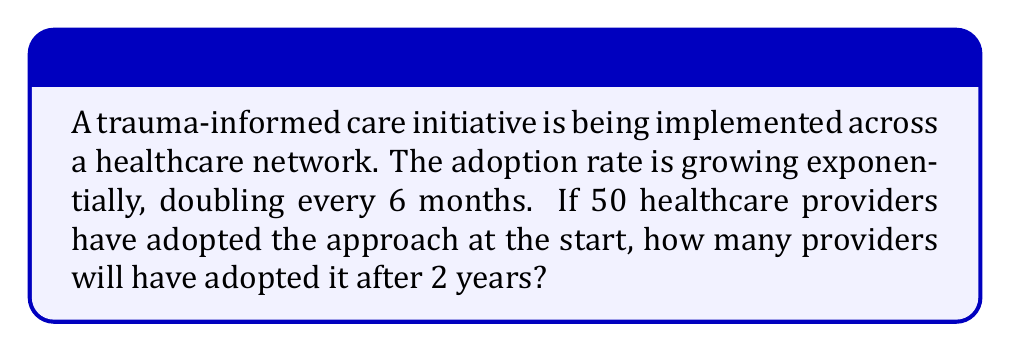Can you solve this math problem? Let's approach this step-by-step:

1) First, we need to identify our initial value and growth rate:
   - Initial value: $a = 50$ providers
   - Growth rate: doubles every 6 months

2) We can express this as an exponential function:
   $N(t) = a \cdot 2^t$
   where $t$ is the number of 6-month periods

3) We need to calculate for 2 years, which is 4 six-month periods:
   $t = 4$

4) Now we can plug these values into our equation:
   $N(4) = 50 \cdot 2^4$

5) Let's calculate:
   $N(4) = 50 \cdot 16 = 800$

Therefore, after 2 years, 800 healthcare providers will have adopted the trauma-informed care approach.
Answer: 800 providers 